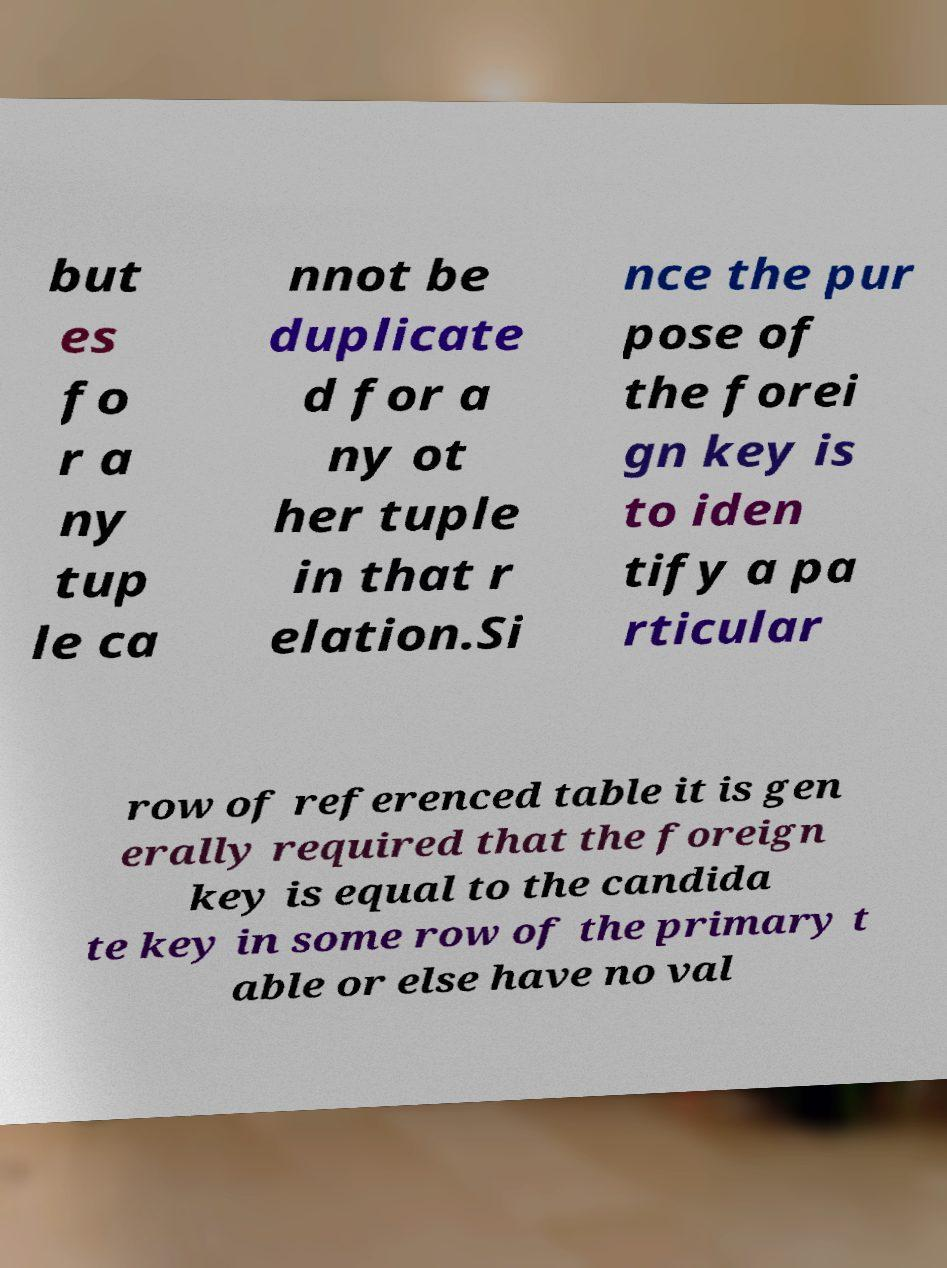For documentation purposes, I need the text within this image transcribed. Could you provide that? but es fo r a ny tup le ca nnot be duplicate d for a ny ot her tuple in that r elation.Si nce the pur pose of the forei gn key is to iden tify a pa rticular row of referenced table it is gen erally required that the foreign key is equal to the candida te key in some row of the primary t able or else have no val 